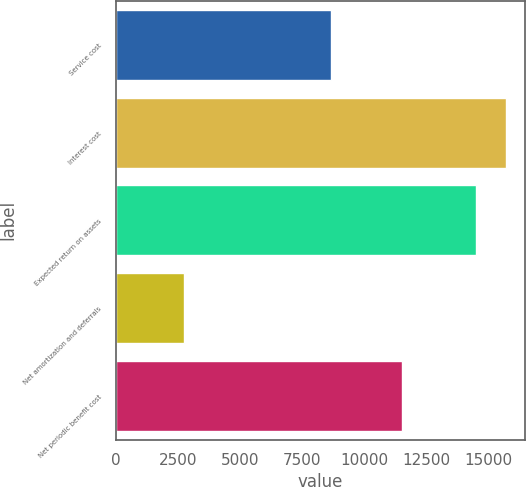Convert chart to OTSL. <chart><loc_0><loc_0><loc_500><loc_500><bar_chart><fcel>Service cost<fcel>Interest cost<fcel>Expected return on assets<fcel>Net amortization and deferrals<fcel>Net periodic benefit cost<nl><fcel>8632<fcel>15677<fcel>14489<fcel>2750<fcel>11523<nl></chart> 